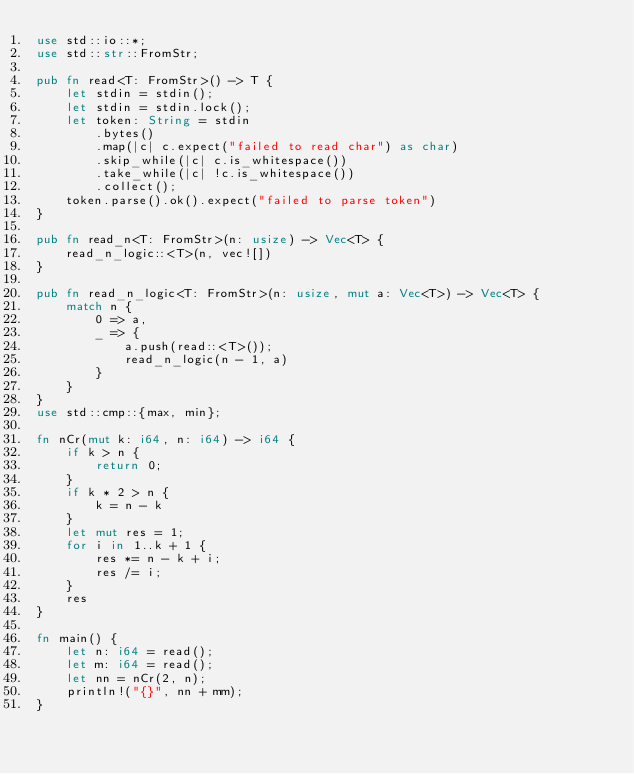<code> <loc_0><loc_0><loc_500><loc_500><_Rust_>use std::io::*;
use std::str::FromStr;

pub fn read<T: FromStr>() -> T {
    let stdin = stdin();
    let stdin = stdin.lock();
    let token: String = stdin
        .bytes()
        .map(|c| c.expect("failed to read char") as char)
        .skip_while(|c| c.is_whitespace())
        .take_while(|c| !c.is_whitespace())
        .collect();
    token.parse().ok().expect("failed to parse token")
}

pub fn read_n<T: FromStr>(n: usize) -> Vec<T> {
    read_n_logic::<T>(n, vec![])
}

pub fn read_n_logic<T: FromStr>(n: usize, mut a: Vec<T>) -> Vec<T> {
    match n {
        0 => a,
        _ => {
            a.push(read::<T>());
            read_n_logic(n - 1, a)
        }
    }
}
use std::cmp::{max, min};

fn nCr(mut k: i64, n: i64) -> i64 {
    if k > n {
        return 0;
    }
    if k * 2 > n {
        k = n - k
    }
    let mut res = 1;
    for i in 1..k + 1 {
        res *= n - k + i;
        res /= i;
    }
    res
}

fn main() {
    let n: i64 = read();
    let m: i64 = read();
    let nn = nCr(2, n);
    println!("{}", nn + mm);
}
</code> 